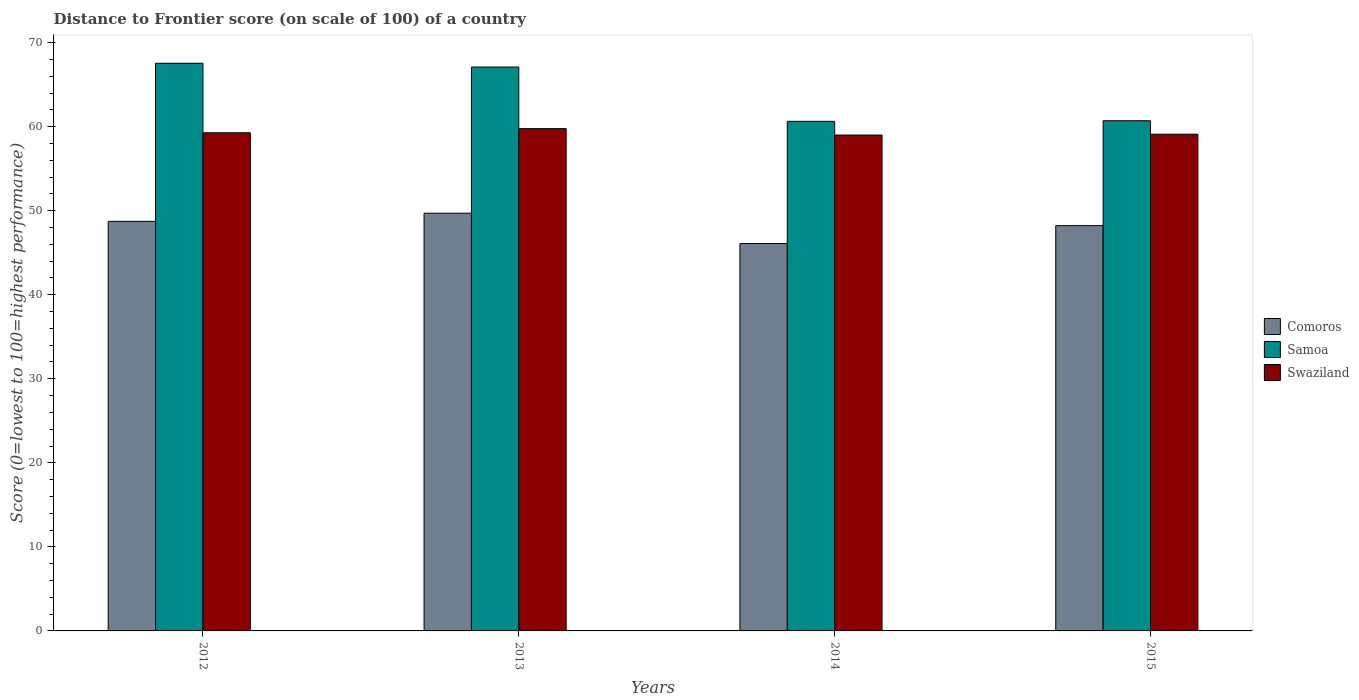How many groups of bars are there?
Your answer should be compact. 4. What is the label of the 2nd group of bars from the left?
Give a very brief answer. 2013. In how many cases, is the number of bars for a given year not equal to the number of legend labels?
Offer a very short reply. 0. Across all years, what is the maximum distance to frontier score of in Comoros?
Give a very brief answer. 49.7. In which year was the distance to frontier score of in Samoa minimum?
Your response must be concise. 2014. What is the total distance to frontier score of in Samoa in the graph?
Keep it short and to the point. 255.96. What is the difference between the distance to frontier score of in Samoa in 2012 and that in 2014?
Offer a terse response. 6.91. What is the difference between the distance to frontier score of in Samoa in 2012 and the distance to frontier score of in Comoros in 2013?
Your response must be concise. 17.84. What is the average distance to frontier score of in Comoros per year?
Give a very brief answer. 48.19. In the year 2012, what is the difference between the distance to frontier score of in Swaziland and distance to frontier score of in Samoa?
Keep it short and to the point. -8.27. What is the ratio of the distance to frontier score of in Comoros in 2012 to that in 2014?
Your answer should be very brief. 1.06. Is the distance to frontier score of in Samoa in 2012 less than that in 2013?
Ensure brevity in your answer.  No. Is the difference between the distance to frontier score of in Swaziland in 2013 and 2014 greater than the difference between the distance to frontier score of in Samoa in 2013 and 2014?
Keep it short and to the point. No. What is the difference between the highest and the second highest distance to frontier score of in Swaziland?
Ensure brevity in your answer.  0.49. What is the difference between the highest and the lowest distance to frontier score of in Samoa?
Provide a short and direct response. 6.91. Is the sum of the distance to frontier score of in Comoros in 2013 and 2015 greater than the maximum distance to frontier score of in Samoa across all years?
Offer a very short reply. Yes. What does the 2nd bar from the left in 2012 represents?
Provide a succinct answer. Samoa. What does the 1st bar from the right in 2013 represents?
Give a very brief answer. Swaziland. Is it the case that in every year, the sum of the distance to frontier score of in Comoros and distance to frontier score of in Swaziland is greater than the distance to frontier score of in Samoa?
Give a very brief answer. Yes. How many bars are there?
Keep it short and to the point. 12. Are all the bars in the graph horizontal?
Your answer should be compact. No. What is the difference between two consecutive major ticks on the Y-axis?
Your response must be concise. 10. How many legend labels are there?
Offer a terse response. 3. How are the legend labels stacked?
Your response must be concise. Vertical. What is the title of the graph?
Your response must be concise. Distance to Frontier score (on scale of 100) of a country. Does "Benin" appear as one of the legend labels in the graph?
Make the answer very short. No. What is the label or title of the X-axis?
Offer a very short reply. Years. What is the label or title of the Y-axis?
Your answer should be very brief. Score (0=lowest to 100=highest performance). What is the Score (0=lowest to 100=highest performance) of Comoros in 2012?
Give a very brief answer. 48.73. What is the Score (0=lowest to 100=highest performance) of Samoa in 2012?
Your answer should be very brief. 67.54. What is the Score (0=lowest to 100=highest performance) in Swaziland in 2012?
Offer a terse response. 59.27. What is the Score (0=lowest to 100=highest performance) of Comoros in 2013?
Your answer should be very brief. 49.7. What is the Score (0=lowest to 100=highest performance) in Samoa in 2013?
Your answer should be compact. 67.09. What is the Score (0=lowest to 100=highest performance) in Swaziland in 2013?
Your answer should be very brief. 59.76. What is the Score (0=lowest to 100=highest performance) of Comoros in 2014?
Ensure brevity in your answer.  46.09. What is the Score (0=lowest to 100=highest performance) of Samoa in 2014?
Make the answer very short. 60.63. What is the Score (0=lowest to 100=highest performance) in Swaziland in 2014?
Make the answer very short. 59. What is the Score (0=lowest to 100=highest performance) of Comoros in 2015?
Your response must be concise. 48.22. What is the Score (0=lowest to 100=highest performance) of Samoa in 2015?
Ensure brevity in your answer.  60.7. What is the Score (0=lowest to 100=highest performance) in Swaziland in 2015?
Give a very brief answer. 59.1. Across all years, what is the maximum Score (0=lowest to 100=highest performance) in Comoros?
Give a very brief answer. 49.7. Across all years, what is the maximum Score (0=lowest to 100=highest performance) of Samoa?
Provide a succinct answer. 67.54. Across all years, what is the maximum Score (0=lowest to 100=highest performance) of Swaziland?
Your response must be concise. 59.76. Across all years, what is the minimum Score (0=lowest to 100=highest performance) of Comoros?
Your response must be concise. 46.09. Across all years, what is the minimum Score (0=lowest to 100=highest performance) in Samoa?
Keep it short and to the point. 60.63. Across all years, what is the minimum Score (0=lowest to 100=highest performance) of Swaziland?
Provide a succinct answer. 59. What is the total Score (0=lowest to 100=highest performance) of Comoros in the graph?
Offer a very short reply. 192.74. What is the total Score (0=lowest to 100=highest performance) in Samoa in the graph?
Provide a short and direct response. 255.96. What is the total Score (0=lowest to 100=highest performance) of Swaziland in the graph?
Offer a terse response. 237.13. What is the difference between the Score (0=lowest to 100=highest performance) in Comoros in 2012 and that in 2013?
Your answer should be compact. -0.97. What is the difference between the Score (0=lowest to 100=highest performance) in Samoa in 2012 and that in 2013?
Your answer should be very brief. 0.45. What is the difference between the Score (0=lowest to 100=highest performance) in Swaziland in 2012 and that in 2013?
Make the answer very short. -0.49. What is the difference between the Score (0=lowest to 100=highest performance) of Comoros in 2012 and that in 2014?
Ensure brevity in your answer.  2.64. What is the difference between the Score (0=lowest to 100=highest performance) of Samoa in 2012 and that in 2014?
Make the answer very short. 6.91. What is the difference between the Score (0=lowest to 100=highest performance) in Swaziland in 2012 and that in 2014?
Provide a succinct answer. 0.27. What is the difference between the Score (0=lowest to 100=highest performance) of Comoros in 2012 and that in 2015?
Offer a terse response. 0.51. What is the difference between the Score (0=lowest to 100=highest performance) of Samoa in 2012 and that in 2015?
Ensure brevity in your answer.  6.84. What is the difference between the Score (0=lowest to 100=highest performance) of Swaziland in 2012 and that in 2015?
Provide a short and direct response. 0.17. What is the difference between the Score (0=lowest to 100=highest performance) of Comoros in 2013 and that in 2014?
Offer a terse response. 3.61. What is the difference between the Score (0=lowest to 100=highest performance) in Samoa in 2013 and that in 2014?
Keep it short and to the point. 6.46. What is the difference between the Score (0=lowest to 100=highest performance) in Swaziland in 2013 and that in 2014?
Ensure brevity in your answer.  0.76. What is the difference between the Score (0=lowest to 100=highest performance) of Comoros in 2013 and that in 2015?
Ensure brevity in your answer.  1.48. What is the difference between the Score (0=lowest to 100=highest performance) of Samoa in 2013 and that in 2015?
Offer a terse response. 6.39. What is the difference between the Score (0=lowest to 100=highest performance) of Swaziland in 2013 and that in 2015?
Keep it short and to the point. 0.66. What is the difference between the Score (0=lowest to 100=highest performance) of Comoros in 2014 and that in 2015?
Provide a short and direct response. -2.13. What is the difference between the Score (0=lowest to 100=highest performance) of Samoa in 2014 and that in 2015?
Your answer should be compact. -0.07. What is the difference between the Score (0=lowest to 100=highest performance) of Swaziland in 2014 and that in 2015?
Provide a short and direct response. -0.1. What is the difference between the Score (0=lowest to 100=highest performance) of Comoros in 2012 and the Score (0=lowest to 100=highest performance) of Samoa in 2013?
Provide a short and direct response. -18.36. What is the difference between the Score (0=lowest to 100=highest performance) in Comoros in 2012 and the Score (0=lowest to 100=highest performance) in Swaziland in 2013?
Your answer should be very brief. -11.03. What is the difference between the Score (0=lowest to 100=highest performance) of Samoa in 2012 and the Score (0=lowest to 100=highest performance) of Swaziland in 2013?
Offer a very short reply. 7.78. What is the difference between the Score (0=lowest to 100=highest performance) of Comoros in 2012 and the Score (0=lowest to 100=highest performance) of Swaziland in 2014?
Offer a very short reply. -10.27. What is the difference between the Score (0=lowest to 100=highest performance) of Samoa in 2012 and the Score (0=lowest to 100=highest performance) of Swaziland in 2014?
Your answer should be very brief. 8.54. What is the difference between the Score (0=lowest to 100=highest performance) in Comoros in 2012 and the Score (0=lowest to 100=highest performance) in Samoa in 2015?
Ensure brevity in your answer.  -11.97. What is the difference between the Score (0=lowest to 100=highest performance) of Comoros in 2012 and the Score (0=lowest to 100=highest performance) of Swaziland in 2015?
Ensure brevity in your answer.  -10.37. What is the difference between the Score (0=lowest to 100=highest performance) of Samoa in 2012 and the Score (0=lowest to 100=highest performance) of Swaziland in 2015?
Your answer should be compact. 8.44. What is the difference between the Score (0=lowest to 100=highest performance) in Comoros in 2013 and the Score (0=lowest to 100=highest performance) in Samoa in 2014?
Give a very brief answer. -10.93. What is the difference between the Score (0=lowest to 100=highest performance) of Samoa in 2013 and the Score (0=lowest to 100=highest performance) of Swaziland in 2014?
Your answer should be compact. 8.09. What is the difference between the Score (0=lowest to 100=highest performance) in Comoros in 2013 and the Score (0=lowest to 100=highest performance) in Samoa in 2015?
Make the answer very short. -11. What is the difference between the Score (0=lowest to 100=highest performance) of Comoros in 2013 and the Score (0=lowest to 100=highest performance) of Swaziland in 2015?
Offer a terse response. -9.4. What is the difference between the Score (0=lowest to 100=highest performance) of Samoa in 2013 and the Score (0=lowest to 100=highest performance) of Swaziland in 2015?
Provide a short and direct response. 7.99. What is the difference between the Score (0=lowest to 100=highest performance) in Comoros in 2014 and the Score (0=lowest to 100=highest performance) in Samoa in 2015?
Keep it short and to the point. -14.61. What is the difference between the Score (0=lowest to 100=highest performance) of Comoros in 2014 and the Score (0=lowest to 100=highest performance) of Swaziland in 2015?
Ensure brevity in your answer.  -13.01. What is the difference between the Score (0=lowest to 100=highest performance) in Samoa in 2014 and the Score (0=lowest to 100=highest performance) in Swaziland in 2015?
Offer a terse response. 1.53. What is the average Score (0=lowest to 100=highest performance) of Comoros per year?
Your answer should be very brief. 48.19. What is the average Score (0=lowest to 100=highest performance) in Samoa per year?
Provide a short and direct response. 63.99. What is the average Score (0=lowest to 100=highest performance) of Swaziland per year?
Give a very brief answer. 59.28. In the year 2012, what is the difference between the Score (0=lowest to 100=highest performance) of Comoros and Score (0=lowest to 100=highest performance) of Samoa?
Provide a succinct answer. -18.81. In the year 2012, what is the difference between the Score (0=lowest to 100=highest performance) in Comoros and Score (0=lowest to 100=highest performance) in Swaziland?
Provide a succinct answer. -10.54. In the year 2012, what is the difference between the Score (0=lowest to 100=highest performance) in Samoa and Score (0=lowest to 100=highest performance) in Swaziland?
Provide a succinct answer. 8.27. In the year 2013, what is the difference between the Score (0=lowest to 100=highest performance) in Comoros and Score (0=lowest to 100=highest performance) in Samoa?
Your answer should be very brief. -17.39. In the year 2013, what is the difference between the Score (0=lowest to 100=highest performance) of Comoros and Score (0=lowest to 100=highest performance) of Swaziland?
Keep it short and to the point. -10.06. In the year 2013, what is the difference between the Score (0=lowest to 100=highest performance) of Samoa and Score (0=lowest to 100=highest performance) of Swaziland?
Your response must be concise. 7.33. In the year 2014, what is the difference between the Score (0=lowest to 100=highest performance) of Comoros and Score (0=lowest to 100=highest performance) of Samoa?
Keep it short and to the point. -14.54. In the year 2014, what is the difference between the Score (0=lowest to 100=highest performance) in Comoros and Score (0=lowest to 100=highest performance) in Swaziland?
Provide a succinct answer. -12.91. In the year 2014, what is the difference between the Score (0=lowest to 100=highest performance) in Samoa and Score (0=lowest to 100=highest performance) in Swaziland?
Your answer should be compact. 1.63. In the year 2015, what is the difference between the Score (0=lowest to 100=highest performance) of Comoros and Score (0=lowest to 100=highest performance) of Samoa?
Make the answer very short. -12.48. In the year 2015, what is the difference between the Score (0=lowest to 100=highest performance) in Comoros and Score (0=lowest to 100=highest performance) in Swaziland?
Keep it short and to the point. -10.88. What is the ratio of the Score (0=lowest to 100=highest performance) in Comoros in 2012 to that in 2013?
Keep it short and to the point. 0.98. What is the ratio of the Score (0=lowest to 100=highest performance) in Samoa in 2012 to that in 2013?
Offer a terse response. 1.01. What is the ratio of the Score (0=lowest to 100=highest performance) in Comoros in 2012 to that in 2014?
Provide a short and direct response. 1.06. What is the ratio of the Score (0=lowest to 100=highest performance) in Samoa in 2012 to that in 2014?
Keep it short and to the point. 1.11. What is the ratio of the Score (0=lowest to 100=highest performance) in Swaziland in 2012 to that in 2014?
Provide a succinct answer. 1. What is the ratio of the Score (0=lowest to 100=highest performance) of Comoros in 2012 to that in 2015?
Your response must be concise. 1.01. What is the ratio of the Score (0=lowest to 100=highest performance) in Samoa in 2012 to that in 2015?
Make the answer very short. 1.11. What is the ratio of the Score (0=lowest to 100=highest performance) in Swaziland in 2012 to that in 2015?
Ensure brevity in your answer.  1. What is the ratio of the Score (0=lowest to 100=highest performance) in Comoros in 2013 to that in 2014?
Your response must be concise. 1.08. What is the ratio of the Score (0=lowest to 100=highest performance) in Samoa in 2013 to that in 2014?
Ensure brevity in your answer.  1.11. What is the ratio of the Score (0=lowest to 100=highest performance) of Swaziland in 2013 to that in 2014?
Offer a very short reply. 1.01. What is the ratio of the Score (0=lowest to 100=highest performance) in Comoros in 2013 to that in 2015?
Offer a terse response. 1.03. What is the ratio of the Score (0=lowest to 100=highest performance) in Samoa in 2013 to that in 2015?
Provide a short and direct response. 1.11. What is the ratio of the Score (0=lowest to 100=highest performance) in Swaziland in 2013 to that in 2015?
Keep it short and to the point. 1.01. What is the ratio of the Score (0=lowest to 100=highest performance) in Comoros in 2014 to that in 2015?
Your response must be concise. 0.96. What is the ratio of the Score (0=lowest to 100=highest performance) of Samoa in 2014 to that in 2015?
Offer a terse response. 1. What is the ratio of the Score (0=lowest to 100=highest performance) in Swaziland in 2014 to that in 2015?
Make the answer very short. 1. What is the difference between the highest and the second highest Score (0=lowest to 100=highest performance) of Samoa?
Ensure brevity in your answer.  0.45. What is the difference between the highest and the second highest Score (0=lowest to 100=highest performance) in Swaziland?
Keep it short and to the point. 0.49. What is the difference between the highest and the lowest Score (0=lowest to 100=highest performance) in Comoros?
Give a very brief answer. 3.61. What is the difference between the highest and the lowest Score (0=lowest to 100=highest performance) of Samoa?
Provide a short and direct response. 6.91. What is the difference between the highest and the lowest Score (0=lowest to 100=highest performance) of Swaziland?
Keep it short and to the point. 0.76. 